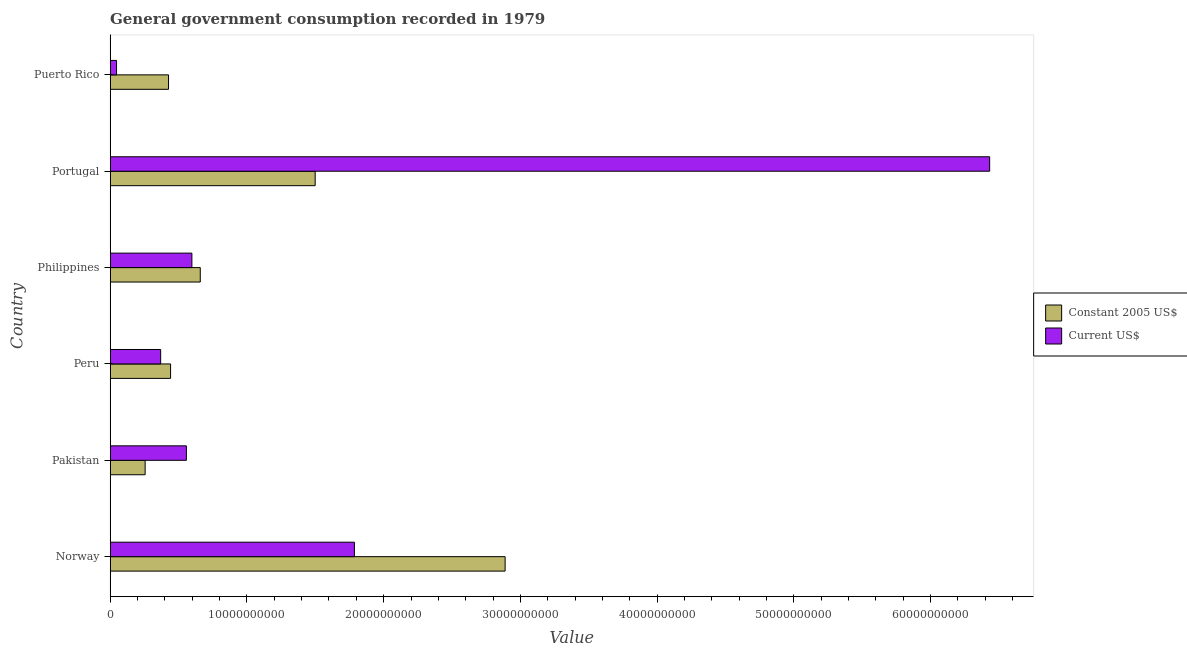How many different coloured bars are there?
Make the answer very short. 2. How many groups of bars are there?
Make the answer very short. 6. Are the number of bars per tick equal to the number of legend labels?
Make the answer very short. Yes. Are the number of bars on each tick of the Y-axis equal?
Ensure brevity in your answer.  Yes. How many bars are there on the 1st tick from the top?
Ensure brevity in your answer.  2. What is the label of the 6th group of bars from the top?
Your answer should be very brief. Norway. In how many cases, is the number of bars for a given country not equal to the number of legend labels?
Ensure brevity in your answer.  0. What is the value consumed in current us$ in Puerto Rico?
Offer a very short reply. 4.67e+08. Across all countries, what is the maximum value consumed in current us$?
Your answer should be very brief. 6.43e+1. Across all countries, what is the minimum value consumed in current us$?
Offer a very short reply. 4.67e+08. In which country was the value consumed in constant 2005 us$ maximum?
Give a very brief answer. Norway. In which country was the value consumed in current us$ minimum?
Offer a very short reply. Puerto Rico. What is the total value consumed in current us$ in the graph?
Ensure brevity in your answer.  9.79e+1. What is the difference between the value consumed in constant 2005 us$ in Pakistan and that in Philippines?
Provide a succinct answer. -4.03e+09. What is the difference between the value consumed in constant 2005 us$ in Pakistan and the value consumed in current us$ in Portugal?
Your response must be concise. -6.18e+1. What is the average value consumed in constant 2005 us$ per country?
Offer a terse response. 1.03e+1. What is the difference between the value consumed in current us$ and value consumed in constant 2005 us$ in Norway?
Your answer should be compact. -1.10e+1. What is the ratio of the value consumed in constant 2005 us$ in Portugal to that in Puerto Rico?
Your response must be concise. 3.51. What is the difference between the highest and the second highest value consumed in current us$?
Ensure brevity in your answer.  4.65e+1. What is the difference between the highest and the lowest value consumed in current us$?
Your response must be concise. 6.38e+1. In how many countries, is the value consumed in constant 2005 us$ greater than the average value consumed in constant 2005 us$ taken over all countries?
Your answer should be very brief. 2. What does the 2nd bar from the top in Peru represents?
Offer a terse response. Constant 2005 US$. What does the 2nd bar from the bottom in Norway represents?
Your answer should be very brief. Current US$. How many bars are there?
Provide a succinct answer. 12. Are the values on the major ticks of X-axis written in scientific E-notation?
Your answer should be compact. No. Does the graph contain any zero values?
Provide a succinct answer. No. How are the legend labels stacked?
Offer a terse response. Vertical. What is the title of the graph?
Your answer should be very brief. General government consumption recorded in 1979. What is the label or title of the X-axis?
Your response must be concise. Value. What is the label or title of the Y-axis?
Provide a short and direct response. Country. What is the Value of Constant 2005 US$ in Norway?
Ensure brevity in your answer.  2.89e+1. What is the Value of Current US$ in Norway?
Give a very brief answer. 1.79e+1. What is the Value of Constant 2005 US$ in Pakistan?
Your response must be concise. 2.56e+09. What is the Value in Current US$ in Pakistan?
Provide a succinct answer. 5.58e+09. What is the Value in Constant 2005 US$ in Peru?
Keep it short and to the point. 4.42e+09. What is the Value of Current US$ in Peru?
Provide a short and direct response. 3.69e+09. What is the Value in Constant 2005 US$ in Philippines?
Your response must be concise. 6.59e+09. What is the Value in Current US$ in Philippines?
Offer a very short reply. 5.98e+09. What is the Value in Constant 2005 US$ in Portugal?
Provide a succinct answer. 1.50e+1. What is the Value in Current US$ in Portugal?
Give a very brief answer. 6.43e+1. What is the Value of Constant 2005 US$ in Puerto Rico?
Keep it short and to the point. 4.27e+09. What is the Value in Current US$ in Puerto Rico?
Your answer should be compact. 4.67e+08. Across all countries, what is the maximum Value of Constant 2005 US$?
Provide a short and direct response. 2.89e+1. Across all countries, what is the maximum Value in Current US$?
Offer a very short reply. 6.43e+1. Across all countries, what is the minimum Value in Constant 2005 US$?
Your answer should be compact. 2.56e+09. Across all countries, what is the minimum Value of Current US$?
Make the answer very short. 4.67e+08. What is the total Value in Constant 2005 US$ in the graph?
Offer a terse response. 6.17e+1. What is the total Value of Current US$ in the graph?
Keep it short and to the point. 9.79e+1. What is the difference between the Value of Constant 2005 US$ in Norway and that in Pakistan?
Keep it short and to the point. 2.63e+1. What is the difference between the Value in Current US$ in Norway and that in Pakistan?
Your response must be concise. 1.23e+1. What is the difference between the Value of Constant 2005 US$ in Norway and that in Peru?
Provide a succinct answer. 2.45e+1. What is the difference between the Value of Current US$ in Norway and that in Peru?
Your answer should be compact. 1.42e+1. What is the difference between the Value in Constant 2005 US$ in Norway and that in Philippines?
Give a very brief answer. 2.23e+1. What is the difference between the Value of Current US$ in Norway and that in Philippines?
Offer a very short reply. 1.19e+1. What is the difference between the Value of Constant 2005 US$ in Norway and that in Portugal?
Your response must be concise. 1.39e+1. What is the difference between the Value of Current US$ in Norway and that in Portugal?
Offer a terse response. -4.65e+1. What is the difference between the Value of Constant 2005 US$ in Norway and that in Puerto Rico?
Offer a very short reply. 2.46e+1. What is the difference between the Value in Current US$ in Norway and that in Puerto Rico?
Offer a terse response. 1.74e+1. What is the difference between the Value in Constant 2005 US$ in Pakistan and that in Peru?
Provide a short and direct response. -1.86e+09. What is the difference between the Value of Current US$ in Pakistan and that in Peru?
Offer a very short reply. 1.88e+09. What is the difference between the Value in Constant 2005 US$ in Pakistan and that in Philippines?
Offer a terse response. -4.03e+09. What is the difference between the Value of Current US$ in Pakistan and that in Philippines?
Your response must be concise. -4.03e+08. What is the difference between the Value of Constant 2005 US$ in Pakistan and that in Portugal?
Make the answer very short. -1.24e+1. What is the difference between the Value in Current US$ in Pakistan and that in Portugal?
Your answer should be compact. -5.87e+1. What is the difference between the Value of Constant 2005 US$ in Pakistan and that in Puerto Rico?
Offer a terse response. -1.71e+09. What is the difference between the Value in Current US$ in Pakistan and that in Puerto Rico?
Your answer should be compact. 5.11e+09. What is the difference between the Value of Constant 2005 US$ in Peru and that in Philippines?
Your response must be concise. -2.17e+09. What is the difference between the Value of Current US$ in Peru and that in Philippines?
Your answer should be compact. -2.28e+09. What is the difference between the Value in Constant 2005 US$ in Peru and that in Portugal?
Keep it short and to the point. -1.06e+1. What is the difference between the Value of Current US$ in Peru and that in Portugal?
Offer a terse response. -6.06e+1. What is the difference between the Value of Constant 2005 US$ in Peru and that in Puerto Rico?
Provide a succinct answer. 1.51e+08. What is the difference between the Value of Current US$ in Peru and that in Puerto Rico?
Your response must be concise. 3.23e+09. What is the difference between the Value in Constant 2005 US$ in Philippines and that in Portugal?
Keep it short and to the point. -8.40e+09. What is the difference between the Value in Current US$ in Philippines and that in Portugal?
Your answer should be compact. -5.83e+1. What is the difference between the Value in Constant 2005 US$ in Philippines and that in Puerto Rico?
Provide a short and direct response. 2.32e+09. What is the difference between the Value of Current US$ in Philippines and that in Puerto Rico?
Your answer should be compact. 5.51e+09. What is the difference between the Value of Constant 2005 US$ in Portugal and that in Puerto Rico?
Ensure brevity in your answer.  1.07e+1. What is the difference between the Value of Current US$ in Portugal and that in Puerto Rico?
Give a very brief answer. 6.38e+1. What is the difference between the Value in Constant 2005 US$ in Norway and the Value in Current US$ in Pakistan?
Offer a very short reply. 2.33e+1. What is the difference between the Value in Constant 2005 US$ in Norway and the Value in Current US$ in Peru?
Your response must be concise. 2.52e+1. What is the difference between the Value of Constant 2005 US$ in Norway and the Value of Current US$ in Philippines?
Your answer should be very brief. 2.29e+1. What is the difference between the Value of Constant 2005 US$ in Norway and the Value of Current US$ in Portugal?
Your answer should be very brief. -3.54e+1. What is the difference between the Value in Constant 2005 US$ in Norway and the Value in Current US$ in Puerto Rico?
Your answer should be very brief. 2.84e+1. What is the difference between the Value of Constant 2005 US$ in Pakistan and the Value of Current US$ in Peru?
Ensure brevity in your answer.  -1.13e+09. What is the difference between the Value of Constant 2005 US$ in Pakistan and the Value of Current US$ in Philippines?
Offer a terse response. -3.42e+09. What is the difference between the Value of Constant 2005 US$ in Pakistan and the Value of Current US$ in Portugal?
Provide a short and direct response. -6.18e+1. What is the difference between the Value in Constant 2005 US$ in Pakistan and the Value in Current US$ in Puerto Rico?
Your answer should be compact. 2.09e+09. What is the difference between the Value of Constant 2005 US$ in Peru and the Value of Current US$ in Philippines?
Your answer should be very brief. -1.56e+09. What is the difference between the Value in Constant 2005 US$ in Peru and the Value in Current US$ in Portugal?
Keep it short and to the point. -5.99e+1. What is the difference between the Value of Constant 2005 US$ in Peru and the Value of Current US$ in Puerto Rico?
Offer a very short reply. 3.95e+09. What is the difference between the Value in Constant 2005 US$ in Philippines and the Value in Current US$ in Portugal?
Ensure brevity in your answer.  -5.77e+1. What is the difference between the Value of Constant 2005 US$ in Philippines and the Value of Current US$ in Puerto Rico?
Give a very brief answer. 6.12e+09. What is the difference between the Value in Constant 2005 US$ in Portugal and the Value in Current US$ in Puerto Rico?
Give a very brief answer. 1.45e+1. What is the average Value in Constant 2005 US$ per country?
Your answer should be very brief. 1.03e+1. What is the average Value in Current US$ per country?
Your answer should be very brief. 1.63e+1. What is the difference between the Value of Constant 2005 US$ and Value of Current US$ in Norway?
Your answer should be very brief. 1.10e+1. What is the difference between the Value of Constant 2005 US$ and Value of Current US$ in Pakistan?
Offer a very short reply. -3.02e+09. What is the difference between the Value of Constant 2005 US$ and Value of Current US$ in Peru?
Your answer should be very brief. 7.26e+08. What is the difference between the Value of Constant 2005 US$ and Value of Current US$ in Philippines?
Your answer should be very brief. 6.12e+08. What is the difference between the Value in Constant 2005 US$ and Value in Current US$ in Portugal?
Your answer should be compact. -4.93e+1. What is the difference between the Value in Constant 2005 US$ and Value in Current US$ in Puerto Rico?
Your answer should be compact. 3.80e+09. What is the ratio of the Value in Constant 2005 US$ in Norway to that in Pakistan?
Keep it short and to the point. 11.29. What is the ratio of the Value in Current US$ in Norway to that in Pakistan?
Provide a short and direct response. 3.2. What is the ratio of the Value in Constant 2005 US$ in Norway to that in Peru?
Your answer should be compact. 6.54. What is the ratio of the Value in Current US$ in Norway to that in Peru?
Your answer should be compact. 4.84. What is the ratio of the Value of Constant 2005 US$ in Norway to that in Philippines?
Ensure brevity in your answer.  4.38. What is the ratio of the Value in Current US$ in Norway to that in Philippines?
Offer a terse response. 2.99. What is the ratio of the Value of Constant 2005 US$ in Norway to that in Portugal?
Your answer should be very brief. 1.93. What is the ratio of the Value in Current US$ in Norway to that in Portugal?
Your answer should be very brief. 0.28. What is the ratio of the Value of Constant 2005 US$ in Norway to that in Puerto Rico?
Your answer should be very brief. 6.77. What is the ratio of the Value of Current US$ in Norway to that in Puerto Rico?
Give a very brief answer. 38.21. What is the ratio of the Value in Constant 2005 US$ in Pakistan to that in Peru?
Offer a very short reply. 0.58. What is the ratio of the Value of Current US$ in Pakistan to that in Peru?
Offer a terse response. 1.51. What is the ratio of the Value of Constant 2005 US$ in Pakistan to that in Philippines?
Provide a short and direct response. 0.39. What is the ratio of the Value of Current US$ in Pakistan to that in Philippines?
Ensure brevity in your answer.  0.93. What is the ratio of the Value of Constant 2005 US$ in Pakistan to that in Portugal?
Give a very brief answer. 0.17. What is the ratio of the Value of Current US$ in Pakistan to that in Portugal?
Your answer should be compact. 0.09. What is the ratio of the Value in Constant 2005 US$ in Pakistan to that in Puerto Rico?
Your answer should be compact. 0.6. What is the ratio of the Value in Current US$ in Pakistan to that in Puerto Rico?
Your response must be concise. 11.93. What is the ratio of the Value of Constant 2005 US$ in Peru to that in Philippines?
Provide a short and direct response. 0.67. What is the ratio of the Value of Current US$ in Peru to that in Philippines?
Ensure brevity in your answer.  0.62. What is the ratio of the Value of Constant 2005 US$ in Peru to that in Portugal?
Your answer should be compact. 0.29. What is the ratio of the Value in Current US$ in Peru to that in Portugal?
Your response must be concise. 0.06. What is the ratio of the Value of Constant 2005 US$ in Peru to that in Puerto Rico?
Ensure brevity in your answer.  1.04. What is the ratio of the Value in Current US$ in Peru to that in Puerto Rico?
Provide a short and direct response. 7.9. What is the ratio of the Value of Constant 2005 US$ in Philippines to that in Portugal?
Ensure brevity in your answer.  0.44. What is the ratio of the Value in Current US$ in Philippines to that in Portugal?
Provide a succinct answer. 0.09. What is the ratio of the Value of Constant 2005 US$ in Philippines to that in Puerto Rico?
Your answer should be very brief. 1.54. What is the ratio of the Value of Current US$ in Philippines to that in Puerto Rico?
Offer a very short reply. 12.79. What is the ratio of the Value of Constant 2005 US$ in Portugal to that in Puerto Rico?
Make the answer very short. 3.51. What is the ratio of the Value in Current US$ in Portugal to that in Puerto Rico?
Ensure brevity in your answer.  137.58. What is the difference between the highest and the second highest Value of Constant 2005 US$?
Ensure brevity in your answer.  1.39e+1. What is the difference between the highest and the second highest Value in Current US$?
Your answer should be compact. 4.65e+1. What is the difference between the highest and the lowest Value of Constant 2005 US$?
Your answer should be very brief. 2.63e+1. What is the difference between the highest and the lowest Value of Current US$?
Provide a succinct answer. 6.38e+1. 